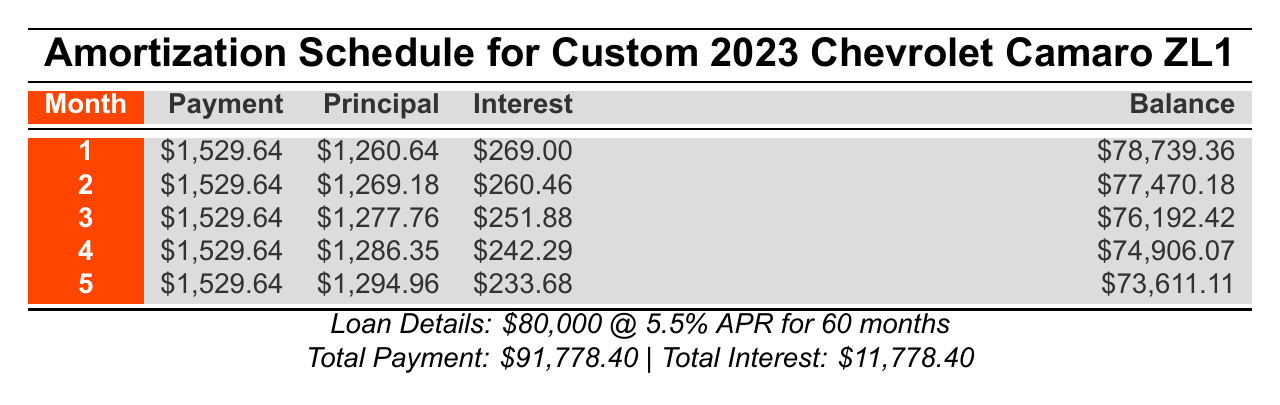What is the total monthly payment for the loan? The table shows that the monthly payment is consistently listed as \$1,529.64 for all months of the schedule.
Answer: 1529.64 How much principal is paid in the first month? From the first month row, the principal payment is \$1,260.64.
Answer: 1260.64 What is the total interest paid during the first five months? To find the total interest over the first five months, I sum the interest payments: 269.00 + 260.46 + 251.88 + 242.29 + 233.68 = 1,257.31.
Answer: 1257.31 Is the interest payment decreasing from month to month? By examining each month's interest payment in the table, I can see that it starts at 269.00 and decreases to 233.68, confirming that it decreases each month.
Answer: Yes How much is the remaining balance at the end of the fifth month? The table indicates that at the end of the fifth month, the remaining balance is \$73,611.11.
Answer: 73611.11 What is the average principal payment made over the first five months? To find the average principal payment, I first sum the principal payments: 1260.64 + 1269.18 + 1277.76 + 1286.35 + 1294.96 = 6,389.89. Then, I divide the total by 5 (the number of months) to get an average of 1,277.98.
Answer: 1277.98 How much total will be paid in interest over the entire loan term? The loan details at the bottom of the table state that the total interest paid is \$11,778.40.
Answer: 11778.40 Did the loan amount have a higher principal or interest payment in the second month? By comparing the second month's principal payment of \$1,269.18 with the interest payment of \$260.46, it's clear that the principal payment is higher.
Answer: Principal How much does the total payment of the loan exceed the principal amount? To find this, I subtract the principal amount from the total payment: \$91,778.40 (total) - \$80,000 (principal) = 11,778.40, which indicates the amount for interest.
Answer: 11778.40 What was the principal payment in the fourth month? According to the table, the principal payment for the fourth month is \$1,286.35.
Answer: 1286.35 